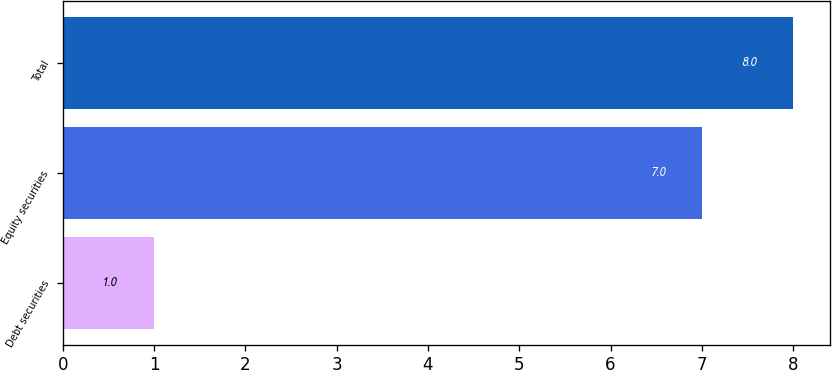Convert chart. <chart><loc_0><loc_0><loc_500><loc_500><bar_chart><fcel>Debt securities<fcel>Equity securities<fcel>Total<nl><fcel>1<fcel>7<fcel>8<nl></chart> 